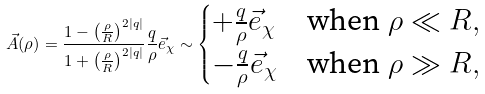Convert formula to latex. <formula><loc_0><loc_0><loc_500><loc_500>\, \vec { A } ( \rho ) = \frac { 1 - \left ( \frac { \rho } { R } \right ) ^ { 2 | q | } } { 1 + \left ( \frac { \rho } { R } \right ) ^ { 2 | q | } } \frac { q } { \rho } \vec { e } _ { \chi } \sim \begin{cases} + \frac { q } { \rho } \vec { e } _ { \chi } & \text {when $\rho\ll R$} , \\ - \frac { q } { \rho } \vec { e } _ { \chi } & \text {when $\rho\gg R$} , \end{cases}</formula> 